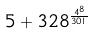Convert formula to latex. <formula><loc_0><loc_0><loc_500><loc_500>5 + 3 2 8 ^ { \frac { 4 ^ { 8 } } { 3 0 1 } }</formula> 